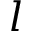Convert formula to latex. <formula><loc_0><loc_0><loc_500><loc_500>l</formula> 